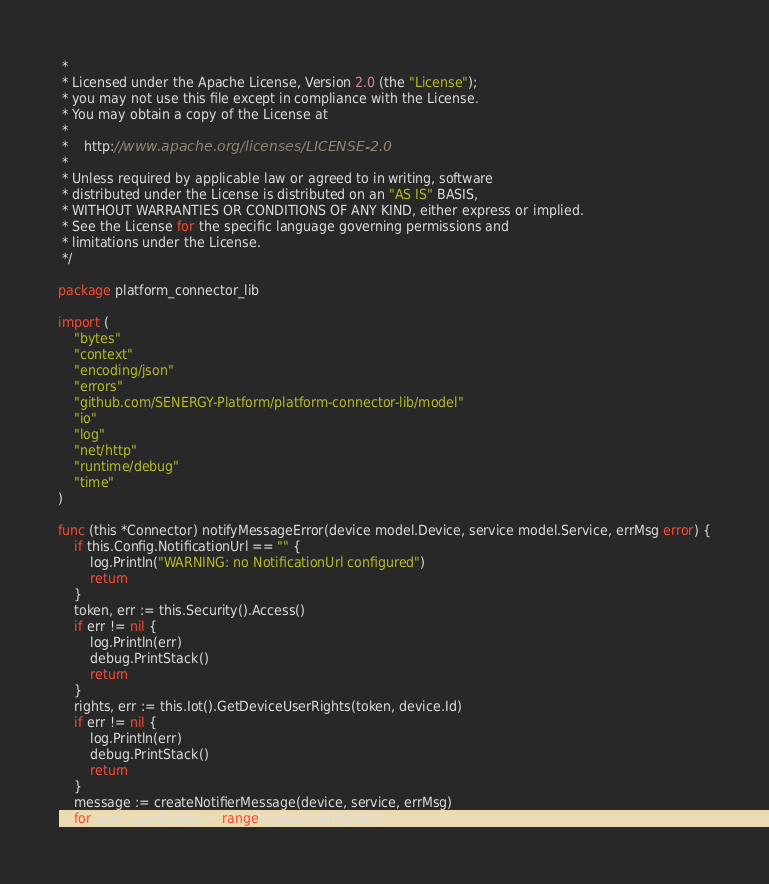<code> <loc_0><loc_0><loc_500><loc_500><_Go_> *
 * Licensed under the Apache License, Version 2.0 (the "License");
 * you may not use this file except in compliance with the License.
 * You may obtain a copy of the License at
 *
 *    http://www.apache.org/licenses/LICENSE-2.0
 *
 * Unless required by applicable law or agreed to in writing, software
 * distributed under the License is distributed on an "AS IS" BASIS,
 * WITHOUT WARRANTIES OR CONDITIONS OF ANY KIND, either express or implied.
 * See the License for the specific language governing permissions and
 * limitations under the License.
 */

package platform_connector_lib

import (
	"bytes"
	"context"
	"encoding/json"
	"errors"
	"github.com/SENERGY-Platform/platform-connector-lib/model"
	"io"
	"log"
	"net/http"
	"runtime/debug"
	"time"
)

func (this *Connector) notifyMessageError(device model.Device, service model.Service, errMsg error) {
	if this.Config.NotificationUrl == "" {
		log.Println("WARNING: no NotificationUrl configured")
		return
	}
	token, err := this.Security().Access()
	if err != nil {
		log.Println(err)
		debug.PrintStack()
		return
	}
	rights, err := this.Iot().GetDeviceUserRights(token, device.Id)
	if err != nil {
		log.Println(err)
		debug.PrintStack()
		return
	}
	message := createNotifierMessage(device, service, errMsg)
	for user, userRights := range rights.UserRights {</code> 